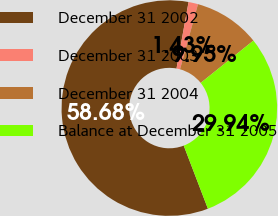Convert chart. <chart><loc_0><loc_0><loc_500><loc_500><pie_chart><fcel>December 31 2002<fcel>December 31 2003<fcel>December 31 2004<fcel>Balance at December 31 2005<nl><fcel>58.68%<fcel>1.43%<fcel>9.95%<fcel>29.94%<nl></chart> 